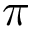<formula> <loc_0><loc_0><loc_500><loc_500>\pi</formula> 